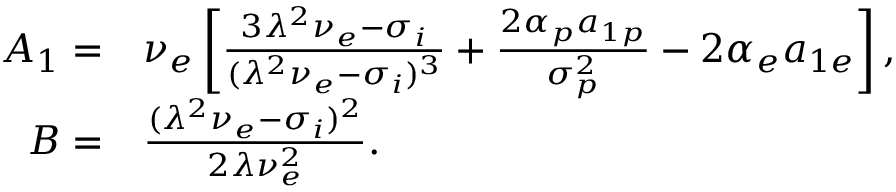Convert formula to latex. <formula><loc_0><loc_0><loc_500><loc_500>\begin{array} { r l } { A _ { 1 } = } & { \nu _ { e } \left [ \frac { 3 \lambda ^ { 2 } \nu _ { e } - \sigma _ { i } } { ( \lambda ^ { 2 } \nu _ { e } - \sigma _ { i } ) ^ { 3 } } + \frac { 2 \alpha _ { p } a _ { 1 p } } { \sigma _ { p } ^ { 2 } } - 2 \alpha _ { e } a _ { 1 e } \right ] , } \\ { B = } & { \frac { ( \lambda ^ { 2 } \nu _ { e } - \sigma _ { i } ) ^ { 2 } } { 2 \lambda \nu _ { e } ^ { 2 } } . } \end{array}</formula> 